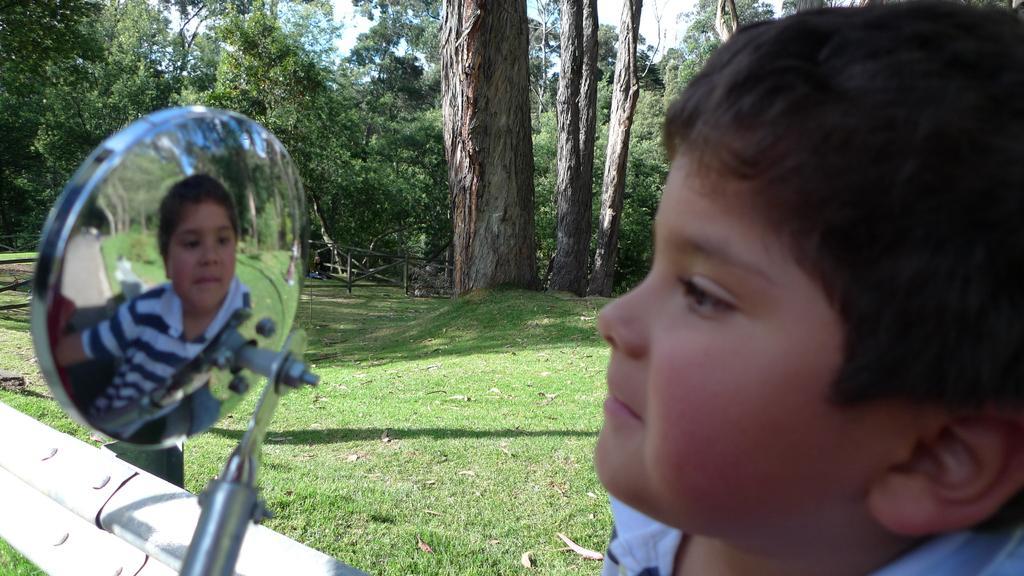Describe this image in one or two sentences. In this image I can see a person face. Back I can see few trees, fencing, the grass and steel object in front. 